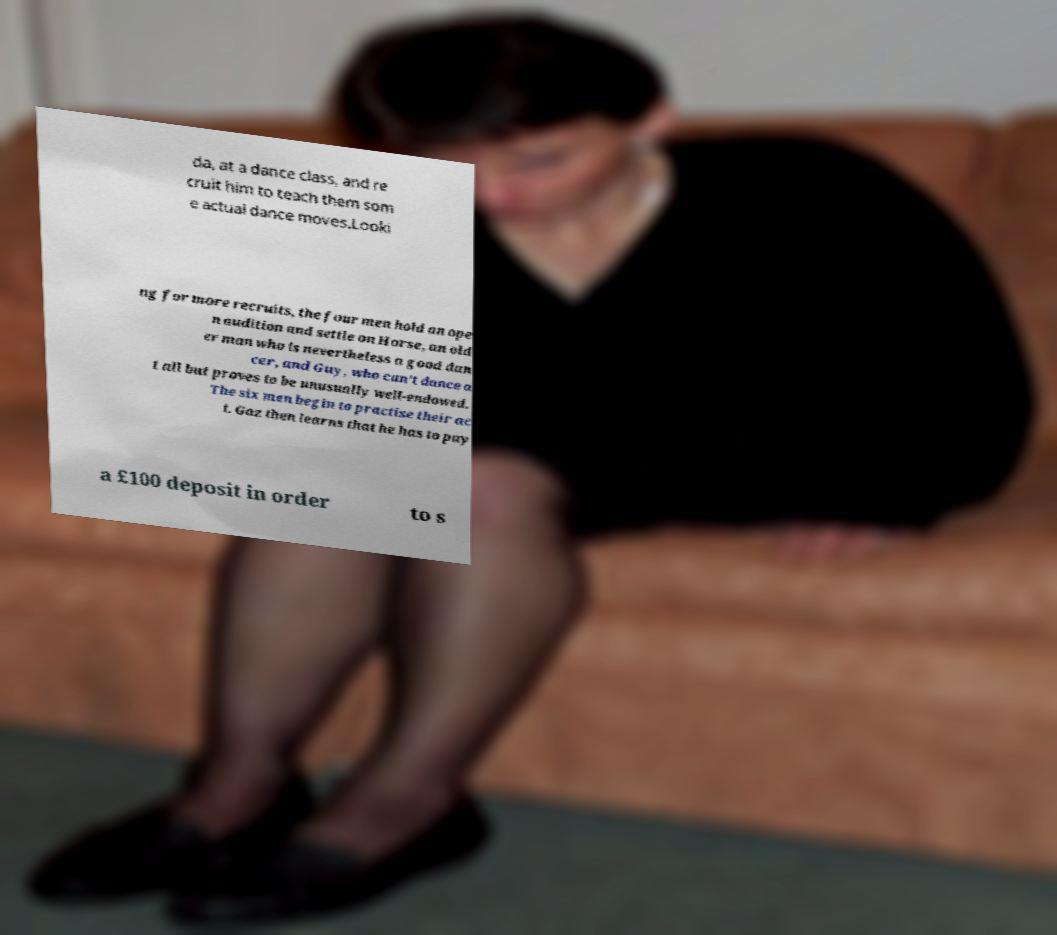Can you read and provide the text displayed in the image?This photo seems to have some interesting text. Can you extract and type it out for me? da, at a dance class, and re cruit him to teach them som e actual dance moves.Looki ng for more recruits, the four men hold an ope n audition and settle on Horse, an old er man who is nevertheless a good dan cer, and Guy, who can't dance a t all but proves to be unusually well-endowed. The six men begin to practise their ac t. Gaz then learns that he has to pay a £100 deposit in order to s 